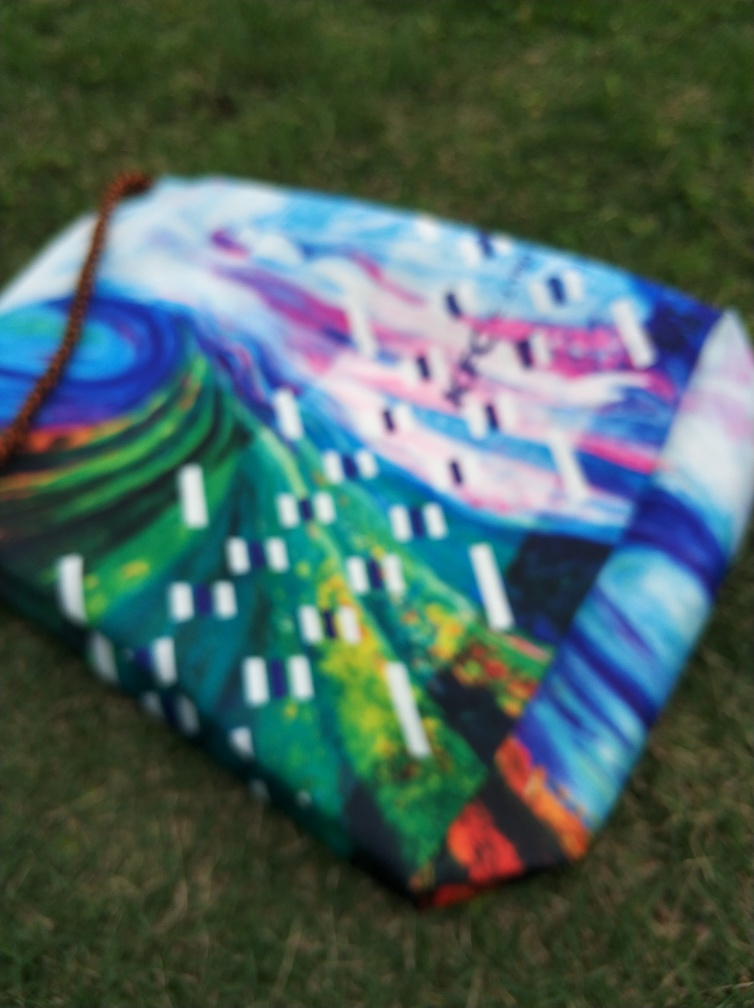What could improve the composition of this picture? To improve the composition, ensuring the camera is steady and the subject is in clear focus would help. Additionally, considering the angle and lighting could better accentuate the artwork's features. What mood does this picture convey? Despite the blurriness, the image's bright, varied colors suggest a joyful and dynamic mood, indicative of a lively abstract piece. 